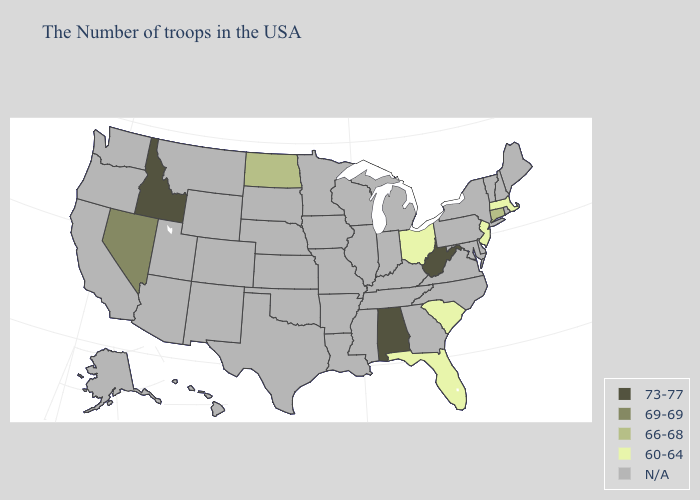Name the states that have a value in the range 60-64?
Short answer required. Massachusetts, New Jersey, South Carolina, Ohio, Florida. Name the states that have a value in the range N/A?
Answer briefly. Maine, Rhode Island, New Hampshire, Vermont, New York, Delaware, Maryland, Pennsylvania, Virginia, North Carolina, Georgia, Michigan, Kentucky, Indiana, Tennessee, Wisconsin, Illinois, Mississippi, Louisiana, Missouri, Arkansas, Minnesota, Iowa, Kansas, Nebraska, Oklahoma, Texas, South Dakota, Wyoming, Colorado, New Mexico, Utah, Montana, Arizona, California, Washington, Oregon, Alaska, Hawaii. What is the highest value in the Northeast ?
Quick response, please. 66-68. What is the highest value in the MidWest ?
Answer briefly. 66-68. Which states hav the highest value in the South?
Answer briefly. West Virginia, Alabama. Does the map have missing data?
Concise answer only. Yes. What is the highest value in states that border Montana?
Answer briefly. 73-77. Name the states that have a value in the range N/A?
Short answer required. Maine, Rhode Island, New Hampshire, Vermont, New York, Delaware, Maryland, Pennsylvania, Virginia, North Carolina, Georgia, Michigan, Kentucky, Indiana, Tennessee, Wisconsin, Illinois, Mississippi, Louisiana, Missouri, Arkansas, Minnesota, Iowa, Kansas, Nebraska, Oklahoma, Texas, South Dakota, Wyoming, Colorado, New Mexico, Utah, Montana, Arizona, California, Washington, Oregon, Alaska, Hawaii. How many symbols are there in the legend?
Concise answer only. 5. Name the states that have a value in the range 60-64?
Keep it brief. Massachusetts, New Jersey, South Carolina, Ohio, Florida. Name the states that have a value in the range 69-69?
Write a very short answer. Nevada. How many symbols are there in the legend?
Be succinct. 5. 